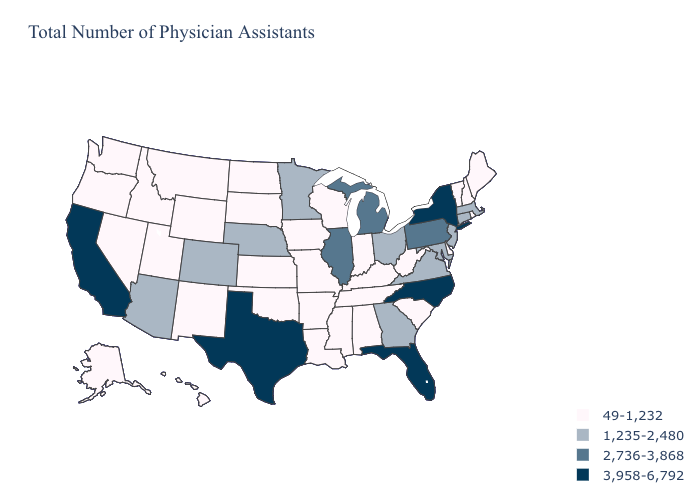Name the states that have a value in the range 2,736-3,868?
Be succinct. Illinois, Michigan, Pennsylvania. Name the states that have a value in the range 2,736-3,868?
Answer briefly. Illinois, Michigan, Pennsylvania. Name the states that have a value in the range 2,736-3,868?
Answer briefly. Illinois, Michigan, Pennsylvania. What is the lowest value in states that border Arkansas?
Short answer required. 49-1,232. What is the value of Maine?
Give a very brief answer. 49-1,232. What is the highest value in the West ?
Keep it brief. 3,958-6,792. Which states have the lowest value in the South?
Quick response, please. Alabama, Arkansas, Delaware, Kentucky, Louisiana, Mississippi, Oklahoma, South Carolina, Tennessee, West Virginia. Does the first symbol in the legend represent the smallest category?
Concise answer only. Yes. Name the states that have a value in the range 3,958-6,792?
Quick response, please. California, Florida, New York, North Carolina, Texas. Which states have the lowest value in the Northeast?
Give a very brief answer. Maine, New Hampshire, Rhode Island, Vermont. What is the value of New Hampshire?
Quick response, please. 49-1,232. Name the states that have a value in the range 49-1,232?
Give a very brief answer. Alabama, Alaska, Arkansas, Delaware, Hawaii, Idaho, Indiana, Iowa, Kansas, Kentucky, Louisiana, Maine, Mississippi, Missouri, Montana, Nevada, New Hampshire, New Mexico, North Dakota, Oklahoma, Oregon, Rhode Island, South Carolina, South Dakota, Tennessee, Utah, Vermont, Washington, West Virginia, Wisconsin, Wyoming. What is the value of Maryland?
Answer briefly. 1,235-2,480. Does the first symbol in the legend represent the smallest category?
Keep it brief. Yes. What is the value of North Carolina?
Write a very short answer. 3,958-6,792. 